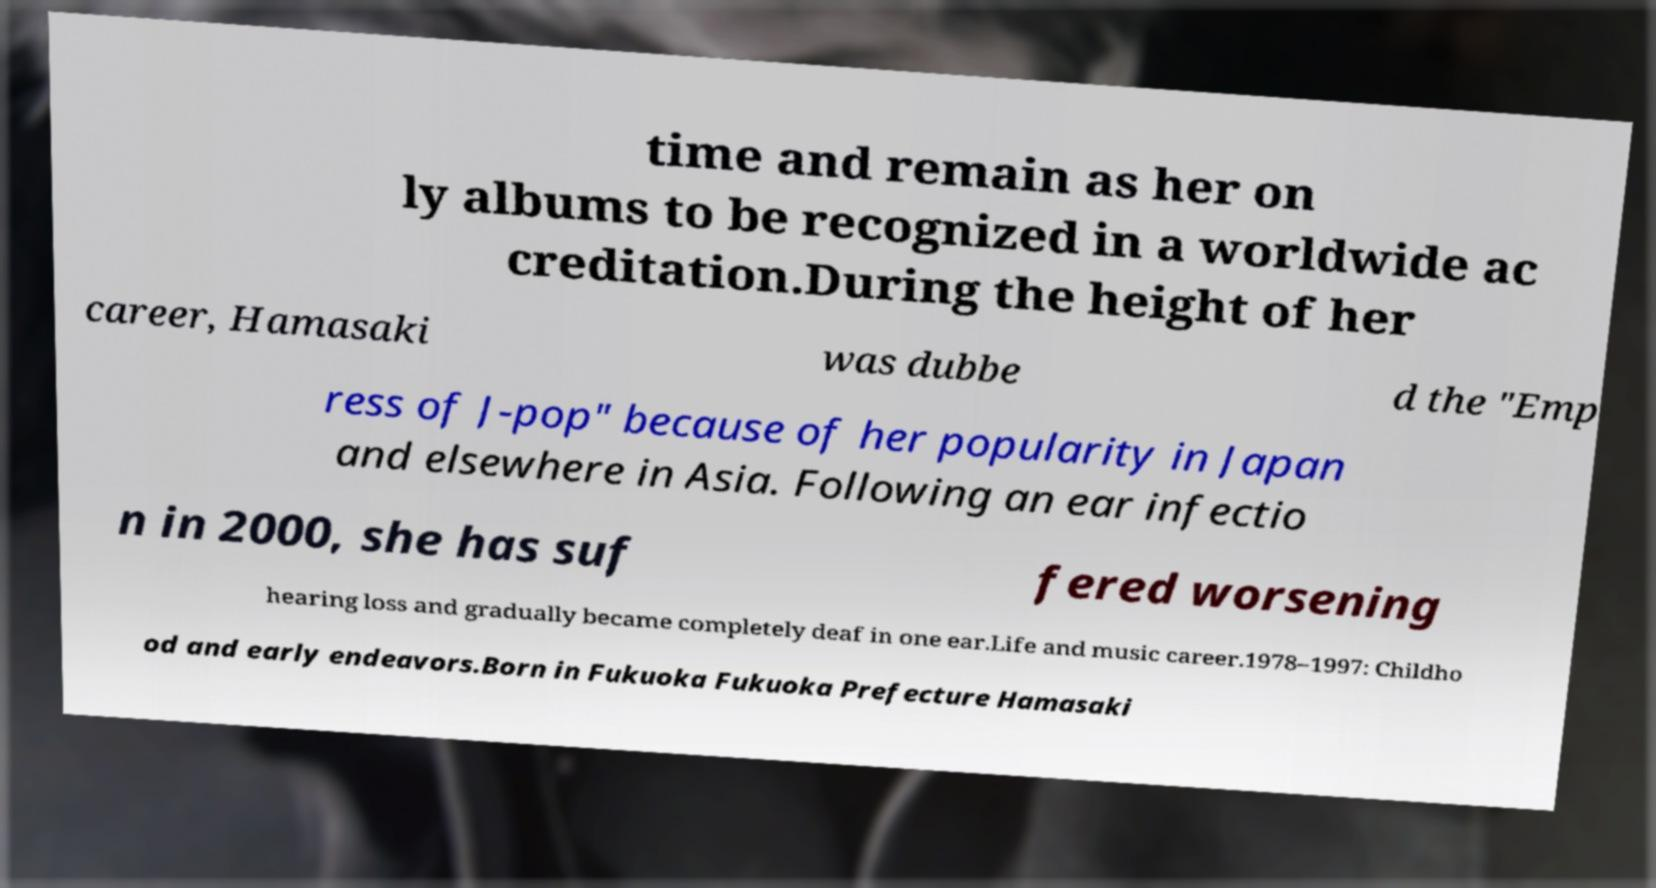What messages or text are displayed in this image? I need them in a readable, typed format. time and remain as her on ly albums to be recognized in a worldwide ac creditation.During the height of her career, Hamasaki was dubbe d the "Emp ress of J-pop" because of her popularity in Japan and elsewhere in Asia. Following an ear infectio n in 2000, she has suf fered worsening hearing loss and gradually became completely deaf in one ear.Life and music career.1978–1997: Childho od and early endeavors.Born in Fukuoka Fukuoka Prefecture Hamasaki 